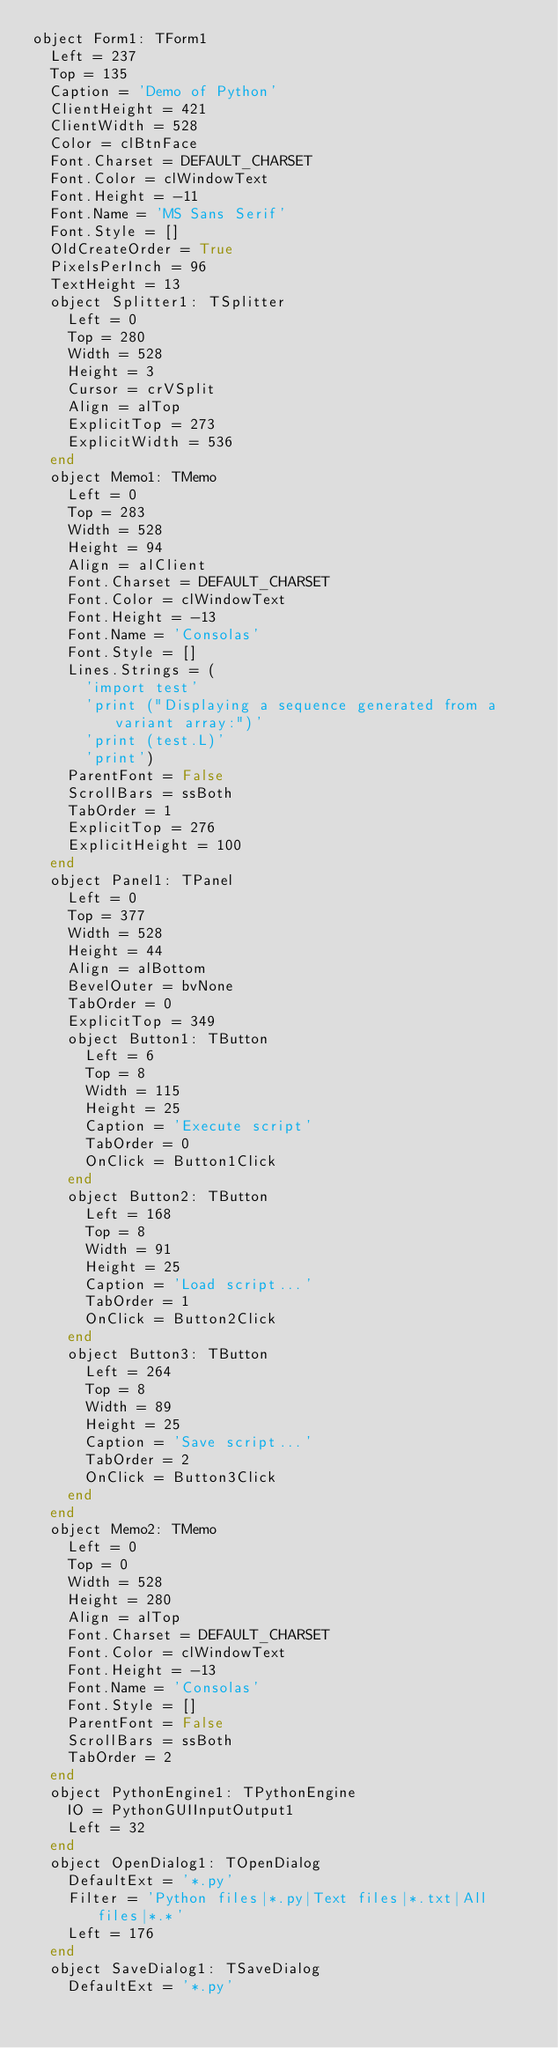Convert code to text. <code><loc_0><loc_0><loc_500><loc_500><_Pascal_>object Form1: TForm1
  Left = 237
  Top = 135
  Caption = 'Demo of Python'
  ClientHeight = 421
  ClientWidth = 528
  Color = clBtnFace
  Font.Charset = DEFAULT_CHARSET
  Font.Color = clWindowText
  Font.Height = -11
  Font.Name = 'MS Sans Serif'
  Font.Style = []
  OldCreateOrder = True
  PixelsPerInch = 96
  TextHeight = 13
  object Splitter1: TSplitter
    Left = 0
    Top = 280
    Width = 528
    Height = 3
    Cursor = crVSplit
    Align = alTop
    ExplicitTop = 273
    ExplicitWidth = 536
  end
  object Memo1: TMemo
    Left = 0
    Top = 283
    Width = 528
    Height = 94
    Align = alClient
    Font.Charset = DEFAULT_CHARSET
    Font.Color = clWindowText
    Font.Height = -13
    Font.Name = 'Consolas'
    Font.Style = []
    Lines.Strings = (
      'import test'
      'print ("Displaying a sequence generated from a variant array:")'
      'print (test.L)'
      'print')
    ParentFont = False
    ScrollBars = ssBoth
    TabOrder = 1
    ExplicitTop = 276
    ExplicitHeight = 100
  end
  object Panel1: TPanel
    Left = 0
    Top = 377
    Width = 528
    Height = 44
    Align = alBottom
    BevelOuter = bvNone
    TabOrder = 0
    ExplicitTop = 349
    object Button1: TButton
      Left = 6
      Top = 8
      Width = 115
      Height = 25
      Caption = 'Execute script'
      TabOrder = 0
      OnClick = Button1Click
    end
    object Button2: TButton
      Left = 168
      Top = 8
      Width = 91
      Height = 25
      Caption = 'Load script...'
      TabOrder = 1
      OnClick = Button2Click
    end
    object Button3: TButton
      Left = 264
      Top = 8
      Width = 89
      Height = 25
      Caption = 'Save script...'
      TabOrder = 2
      OnClick = Button3Click
    end
  end
  object Memo2: TMemo
    Left = 0
    Top = 0
    Width = 528
    Height = 280
    Align = alTop
    Font.Charset = DEFAULT_CHARSET
    Font.Color = clWindowText
    Font.Height = -13
    Font.Name = 'Consolas'
    Font.Style = []
    ParentFont = False
    ScrollBars = ssBoth
    TabOrder = 2
  end
  object PythonEngine1: TPythonEngine
    IO = PythonGUIInputOutput1
    Left = 32
  end
  object OpenDialog1: TOpenDialog
    DefaultExt = '*.py'
    Filter = 'Python files|*.py|Text files|*.txt|All files|*.*'
    Left = 176
  end
  object SaveDialog1: TSaveDialog
    DefaultExt = '*.py'</code> 